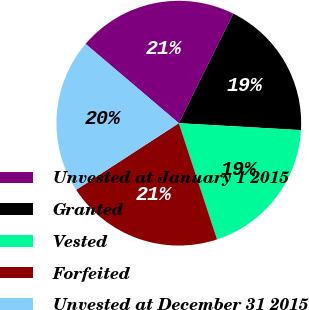Convert chart to OTSL. <chart><loc_0><loc_0><loc_500><loc_500><pie_chart><fcel>Unvested at January 1 2015<fcel>Granted<fcel>Vested<fcel>Forfeited<fcel>Unvested at December 31 2015<nl><fcel>21.14%<fcel>18.55%<fcel>19.04%<fcel>20.89%<fcel>20.38%<nl></chart> 